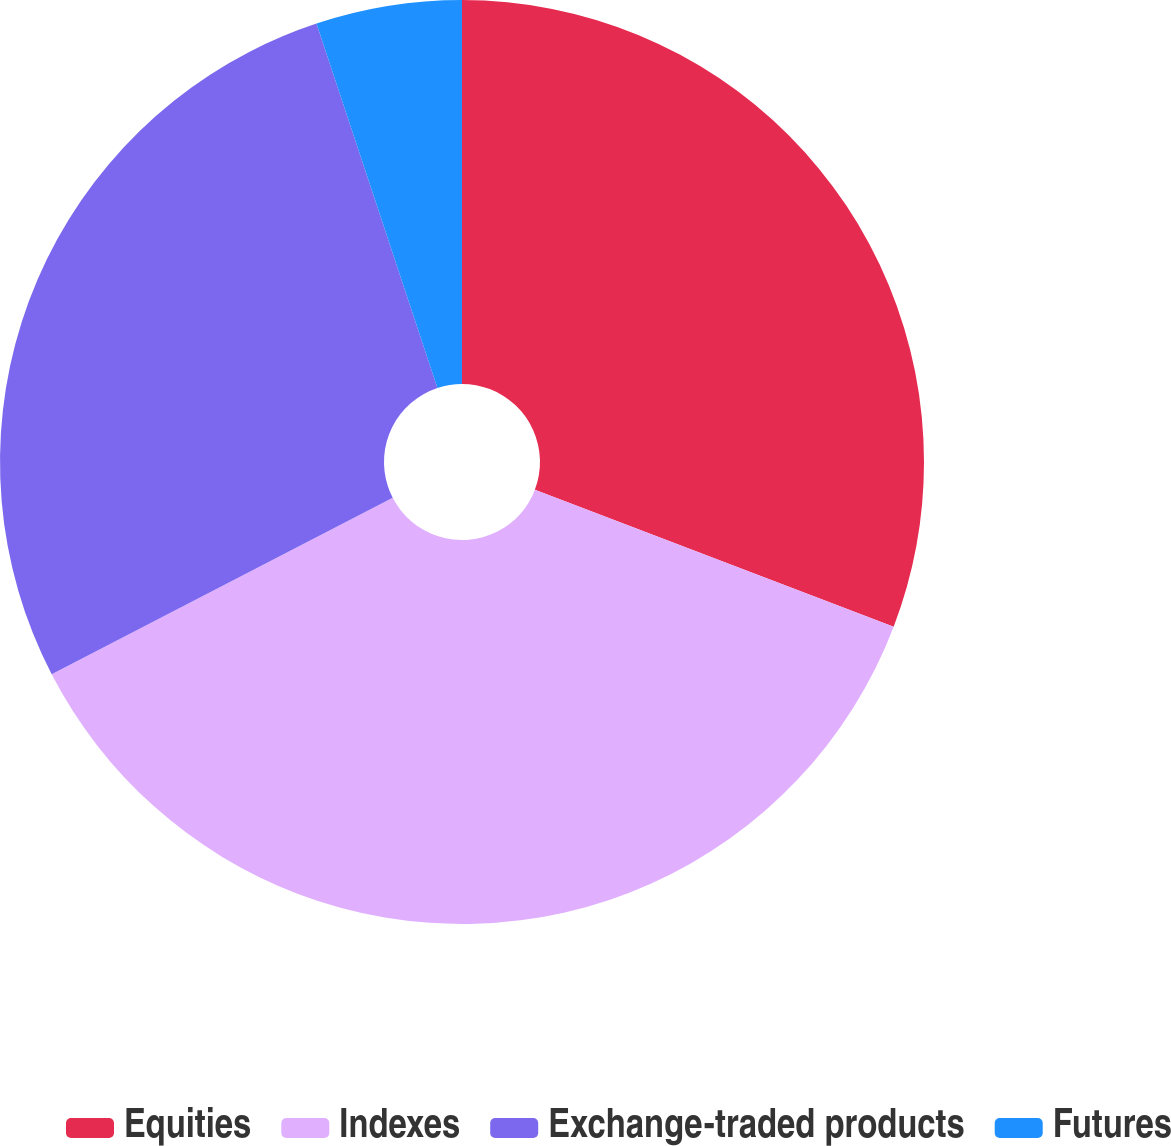<chart> <loc_0><loc_0><loc_500><loc_500><pie_chart><fcel>Equities<fcel>Indexes<fcel>Exchange-traded products<fcel>Futures<nl><fcel>30.8%<fcel>36.6%<fcel>27.5%<fcel>5.1%<nl></chart> 